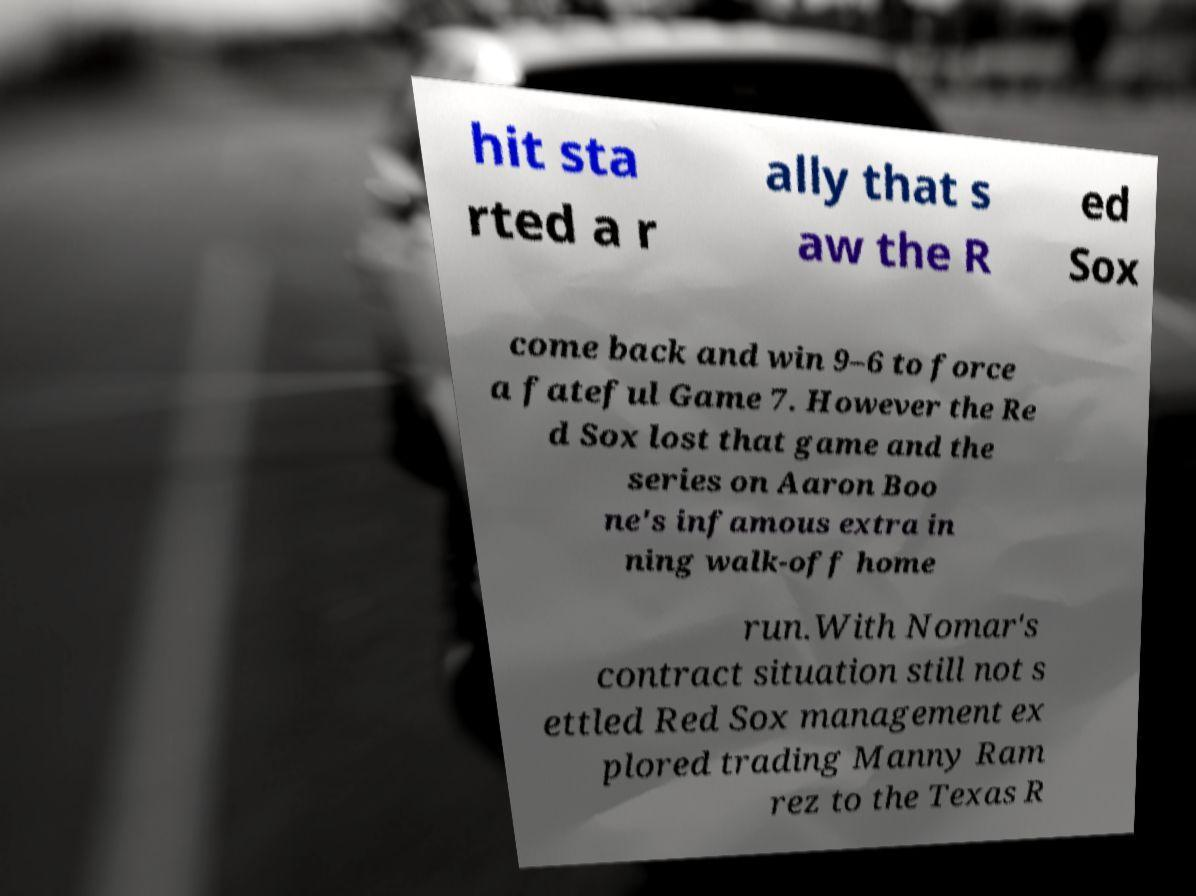There's text embedded in this image that I need extracted. Can you transcribe it verbatim? hit sta rted a r ally that s aw the R ed Sox come back and win 9–6 to force a fateful Game 7. However the Re d Sox lost that game and the series on Aaron Boo ne's infamous extra in ning walk-off home run.With Nomar's contract situation still not s ettled Red Sox management ex plored trading Manny Ram rez to the Texas R 